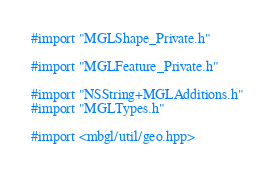Convert code to text. <code><loc_0><loc_0><loc_500><loc_500><_ObjectiveC_>#import "MGLShape_Private.h"

#import "MGLFeature_Private.h"

#import "NSString+MGLAdditions.h"
#import "MGLTypes.h"

#import <mbgl/util/geo.hpp>
</code> 